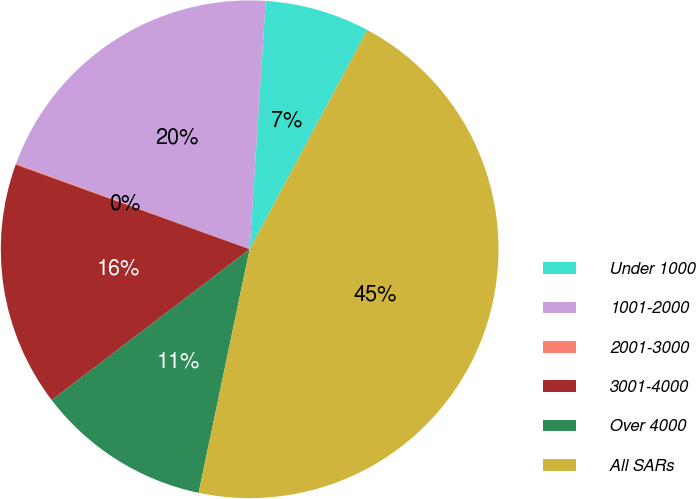<chart> <loc_0><loc_0><loc_500><loc_500><pie_chart><fcel>Under 1000<fcel>1001-2000<fcel>2001-3000<fcel>3001-4000<fcel>Over 4000<fcel>All SARs<nl><fcel>6.81%<fcel>20.43%<fcel>0.07%<fcel>15.89%<fcel>11.35%<fcel>45.46%<nl></chart> 